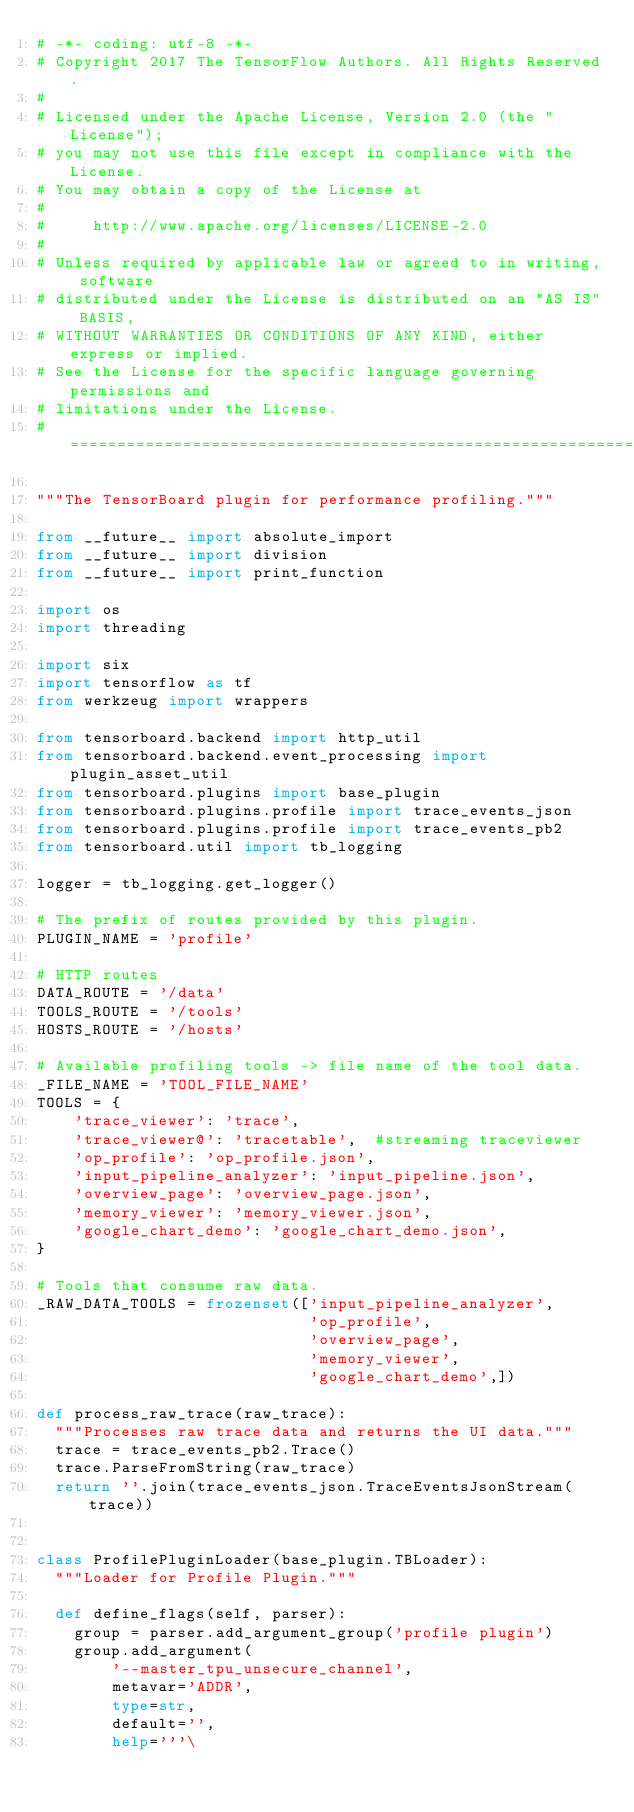<code> <loc_0><loc_0><loc_500><loc_500><_Python_># -*- coding: utf-8 -*-
# Copyright 2017 The TensorFlow Authors. All Rights Reserved.
#
# Licensed under the Apache License, Version 2.0 (the "License");
# you may not use this file except in compliance with the License.
# You may obtain a copy of the License at
#
#     http://www.apache.org/licenses/LICENSE-2.0
#
# Unless required by applicable law or agreed to in writing, software
# distributed under the License is distributed on an "AS IS" BASIS,
# WITHOUT WARRANTIES OR CONDITIONS OF ANY KIND, either express or implied.
# See the License for the specific language governing permissions and
# limitations under the License.
# ==============================================================================

"""The TensorBoard plugin for performance profiling."""

from __future__ import absolute_import
from __future__ import division
from __future__ import print_function

import os
import threading

import six
import tensorflow as tf
from werkzeug import wrappers

from tensorboard.backend import http_util
from tensorboard.backend.event_processing import plugin_asset_util
from tensorboard.plugins import base_plugin
from tensorboard.plugins.profile import trace_events_json
from tensorboard.plugins.profile import trace_events_pb2
from tensorboard.util import tb_logging

logger = tb_logging.get_logger()

# The prefix of routes provided by this plugin.
PLUGIN_NAME = 'profile'

# HTTP routes
DATA_ROUTE = '/data'
TOOLS_ROUTE = '/tools'
HOSTS_ROUTE = '/hosts'

# Available profiling tools -> file name of the tool data.
_FILE_NAME = 'TOOL_FILE_NAME'
TOOLS = {
    'trace_viewer': 'trace',
    'trace_viewer@': 'tracetable',  #streaming traceviewer
    'op_profile': 'op_profile.json',
    'input_pipeline_analyzer': 'input_pipeline.json',
    'overview_page': 'overview_page.json',
    'memory_viewer': 'memory_viewer.json',
    'google_chart_demo': 'google_chart_demo.json',
}

# Tools that consume raw data.
_RAW_DATA_TOOLS = frozenset(['input_pipeline_analyzer',
                             'op_profile',
                             'overview_page',
                             'memory_viewer',
                             'google_chart_demo',])

def process_raw_trace(raw_trace):
  """Processes raw trace data and returns the UI data."""
  trace = trace_events_pb2.Trace()
  trace.ParseFromString(raw_trace)
  return ''.join(trace_events_json.TraceEventsJsonStream(trace))


class ProfilePluginLoader(base_plugin.TBLoader):
  """Loader for Profile Plugin."""

  def define_flags(self, parser):
    group = parser.add_argument_group('profile plugin')
    group.add_argument(
        '--master_tpu_unsecure_channel',
        metavar='ADDR',
        type=str,
        default='',
        help='''\</code> 